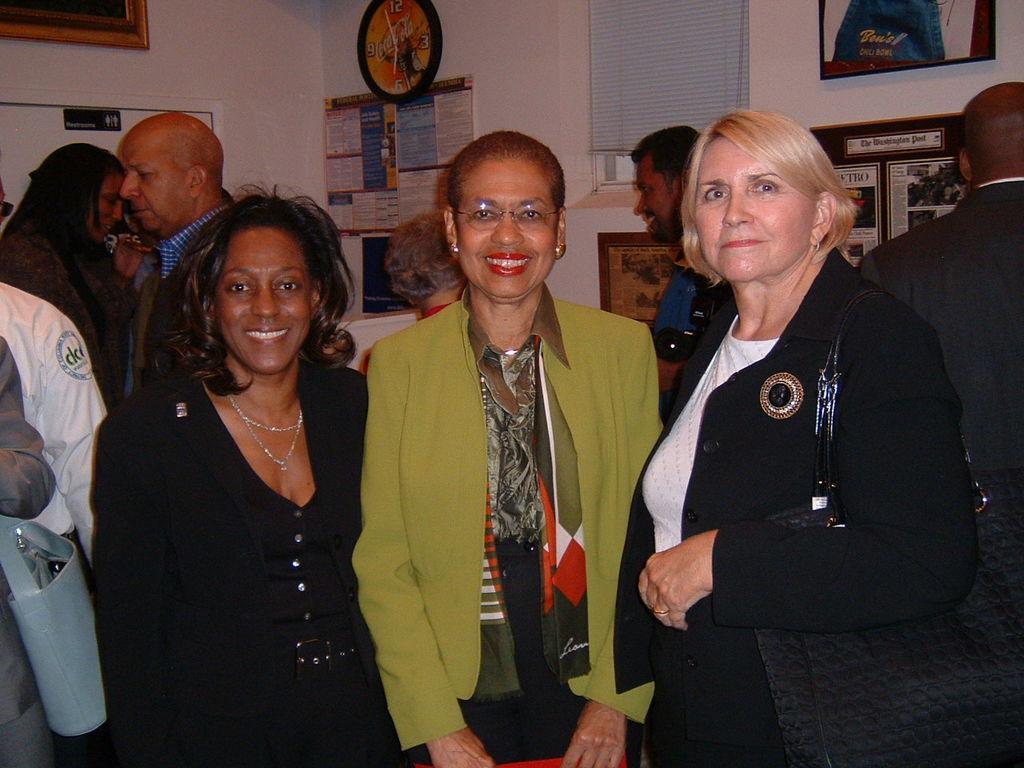Could you give a brief overview of what you see in this image? In this image I can see few people are standing and wearing different color dresses. Back I can see the frames, clock and posters are attached to the wall. I can see the window. 